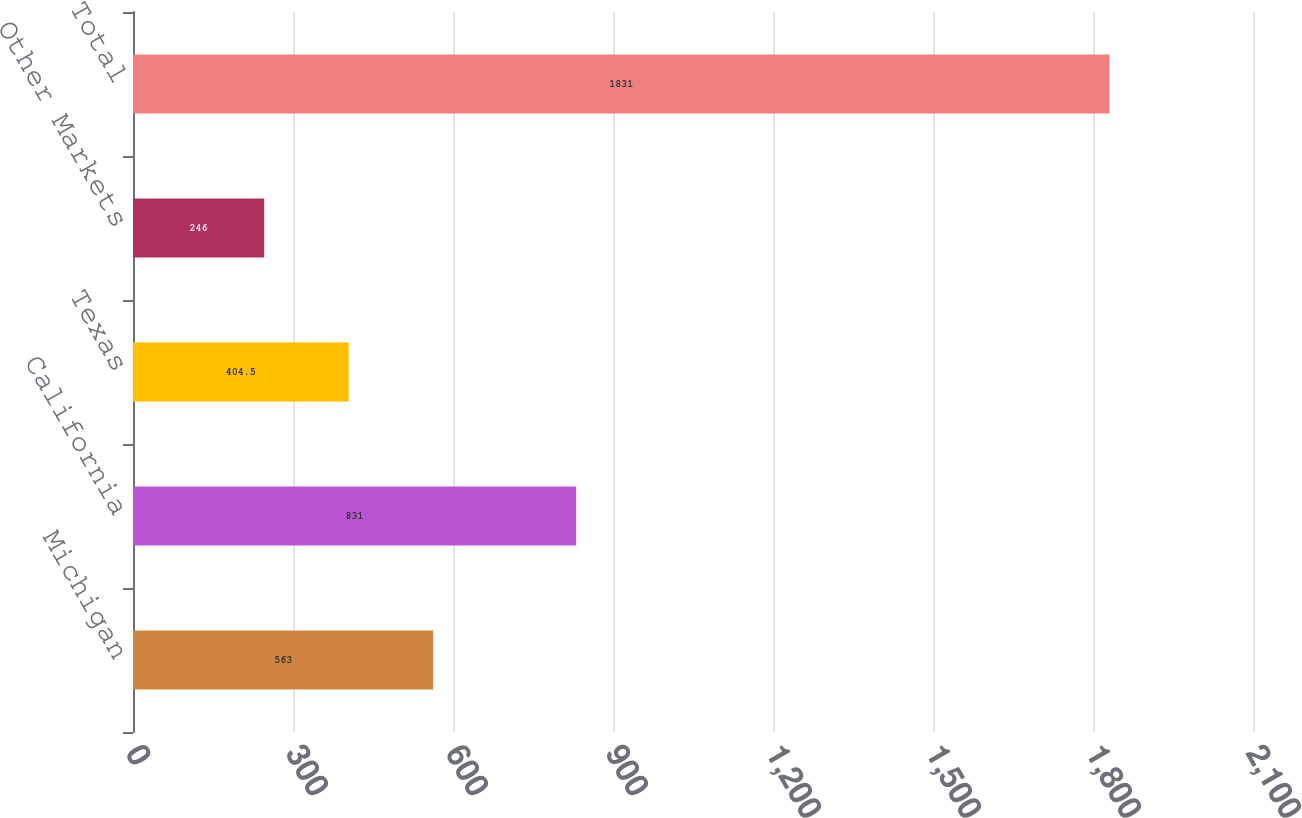<chart> <loc_0><loc_0><loc_500><loc_500><bar_chart><fcel>Michigan<fcel>California<fcel>Texas<fcel>Other Markets<fcel>Total<nl><fcel>563<fcel>831<fcel>404.5<fcel>246<fcel>1831<nl></chart> 